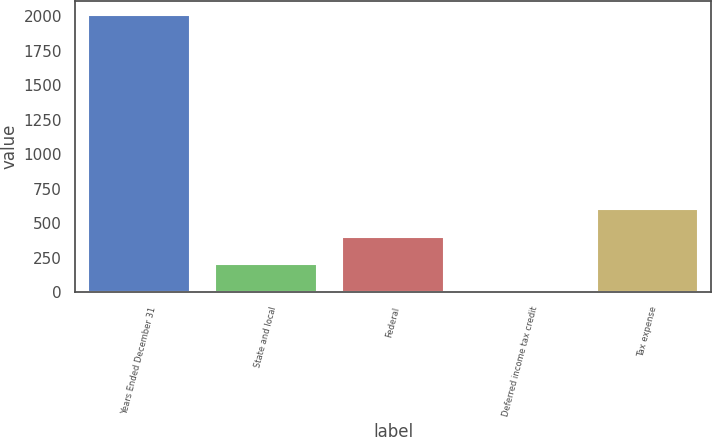Convert chart to OTSL. <chart><loc_0><loc_0><loc_500><loc_500><bar_chart><fcel>Years Ended December 31<fcel>State and local<fcel>Federal<fcel>Deferred income tax credit<fcel>Tax expense<nl><fcel>2013<fcel>204<fcel>405<fcel>3<fcel>606<nl></chart> 